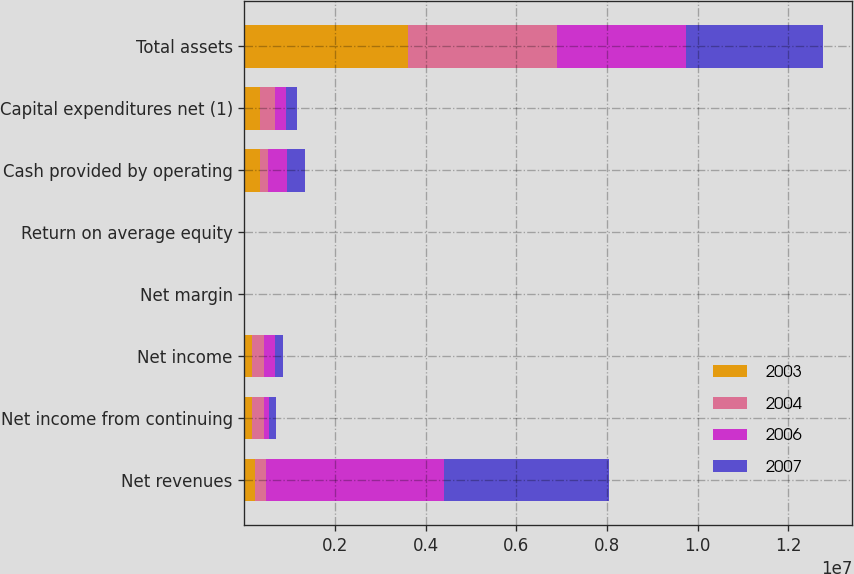<chart> <loc_0><loc_0><loc_500><loc_500><stacked_bar_chart><ecel><fcel>Net revenues<fcel>Net income from continuing<fcel>Net income<fcel>Net margin<fcel>Return on average equity<fcel>Cash provided by operating<fcel>Capital expenditures net (1)<fcel>Total assets<nl><fcel>2003<fcel>235802<fcel>170519<fcel>170387<fcel>3.6<fcel>11.3<fcel>348495<fcel>339813<fcel>3.60866e+06<nl><fcel>2004<fcel>235802<fcel>259594<fcel>259458<fcel>6.2<fcel>18.9<fcel>169239<fcel>341140<fcel>3.27704e+06<nl><fcel>2006<fcel>3.93548e+06<fcel>109843<fcel>240845<fcel>6.1<fcel>19.4<fcel>425426<fcel>241412<fcel>2.85871e+06<nl><fcel>2007<fcel>3.63749e+06<fcel>161098<fcel>169492<fcel>4.7<fcel>14.4<fcel>392880<fcel>230760<fcel>3.02284e+06<nl></chart> 